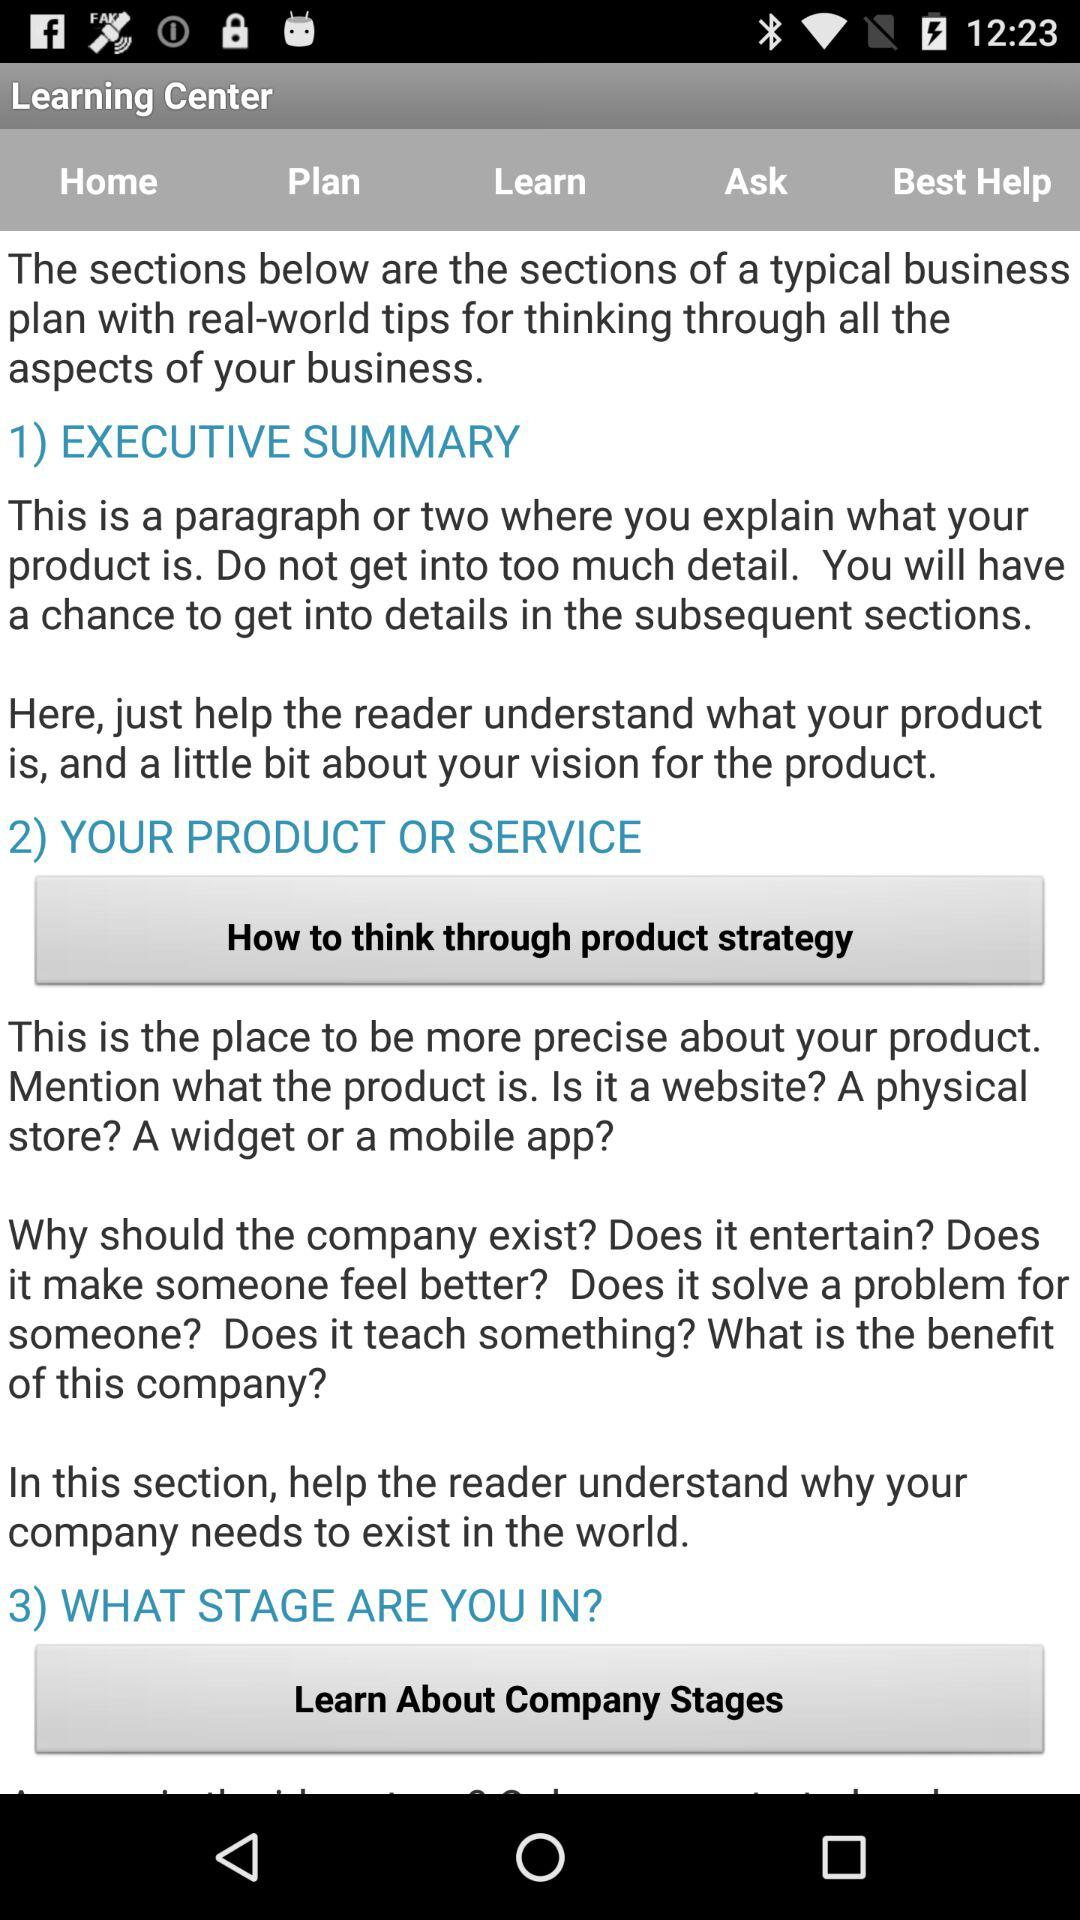How many sections are there in a typical business plan?
Answer the question using a single word or phrase. 3 